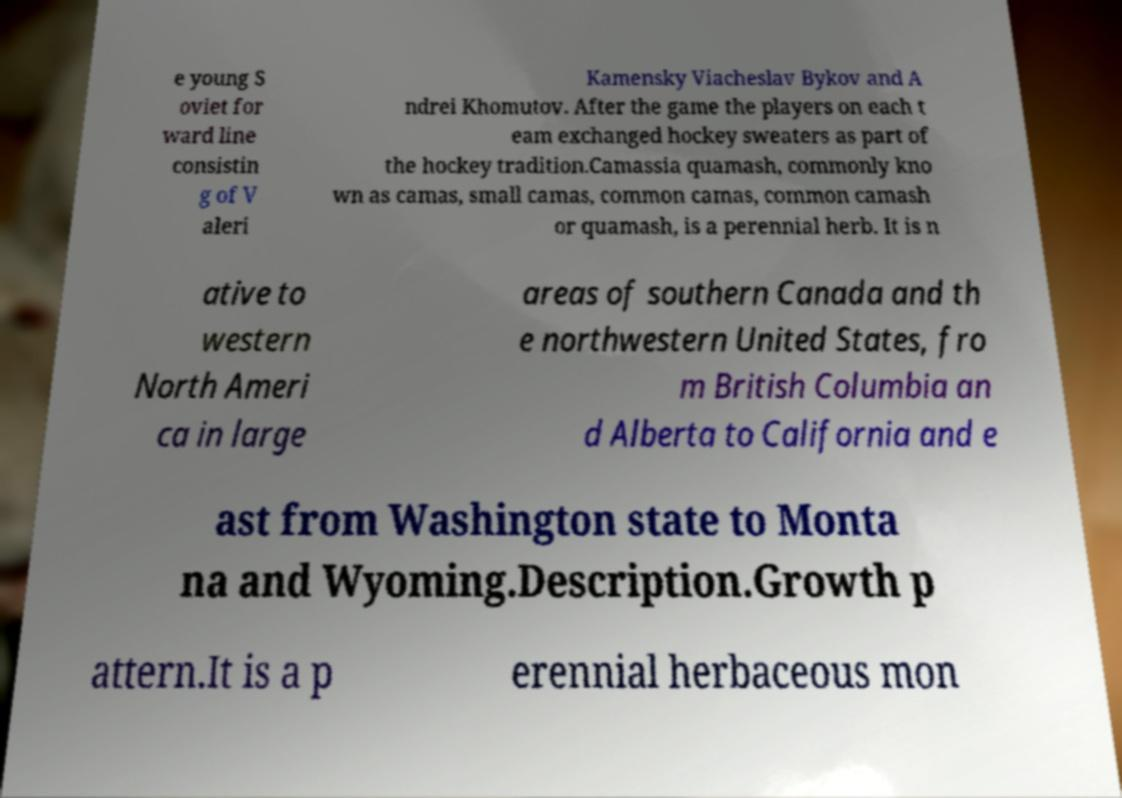For documentation purposes, I need the text within this image transcribed. Could you provide that? e young S oviet for ward line consistin g of V aleri Kamensky Viacheslav Bykov and A ndrei Khomutov. After the game the players on each t eam exchanged hockey sweaters as part of the hockey tradition.Camassia quamash, commonly kno wn as camas, small camas, common camas, common camash or quamash, is a perennial herb. It is n ative to western North Ameri ca in large areas of southern Canada and th e northwestern United States, fro m British Columbia an d Alberta to California and e ast from Washington state to Monta na and Wyoming.Description.Growth p attern.It is a p erennial herbaceous mon 